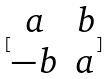<formula> <loc_0><loc_0><loc_500><loc_500>[ \begin{matrix} a & b \\ - b & a \end{matrix} ]</formula> 